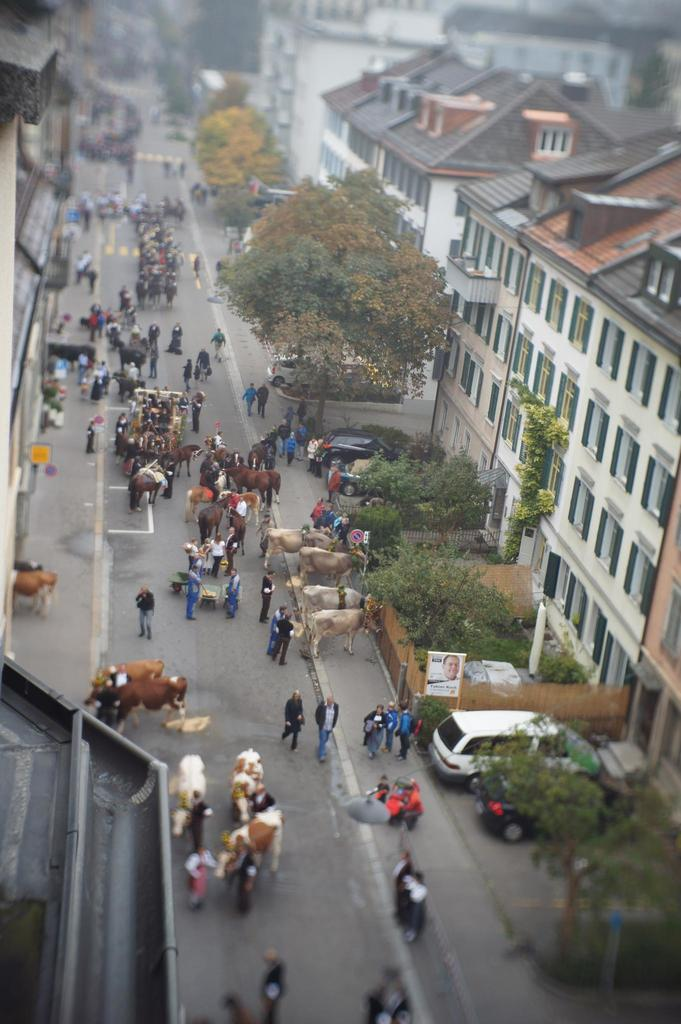How many subjects are present in the image? There are many people and animals in the image. Where are the people and animals located in the image? The people and animals are in the middle of a road. What else can be seen in the image besides people and animals? There are plants and cars in the image. What is the relationship between the cars and the building in the image? The cars are in front of a building. How many pails are being used to transport the animals in the image? There are no pails present in the image, nor are any animals being transported. What type of bikes can be seen in the image? There are no bikes visible in the image. 